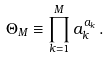Convert formula to latex. <formula><loc_0><loc_0><loc_500><loc_500>\Theta _ { M } \equiv \prod _ { k = 1 } ^ { M } a _ { k } ^ { a _ { k } } \, .</formula> 